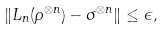Convert formula to latex. <formula><loc_0><loc_0><loc_500><loc_500>\| L _ { n } ( \rho ^ { \otimes n } ) - \sigma ^ { \otimes n } \| \leq \epsilon ,</formula> 